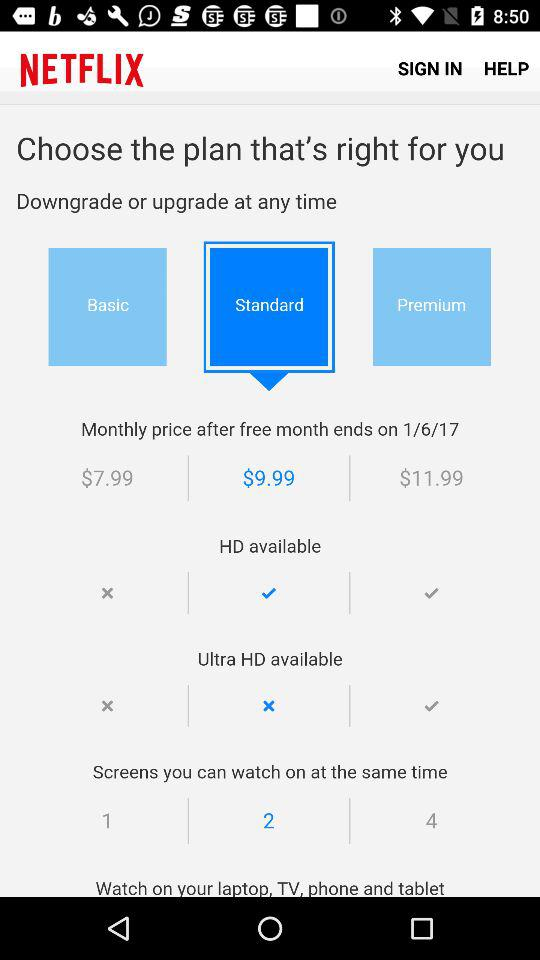Which monthly plan is selected? The selected monthly plan is "Standard". 